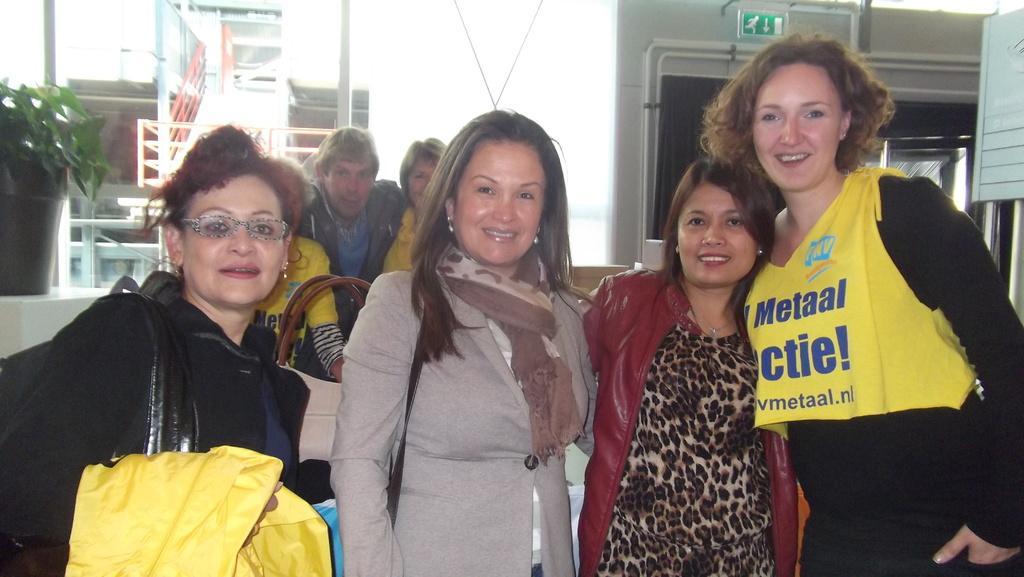In one or two sentences, can you explain what this image depicts? In this image I can see four women are standing and smiling. In the background I can see few other person's, a flower vase, the railing, few buildings, a green colored sign board and the white colored sky. 